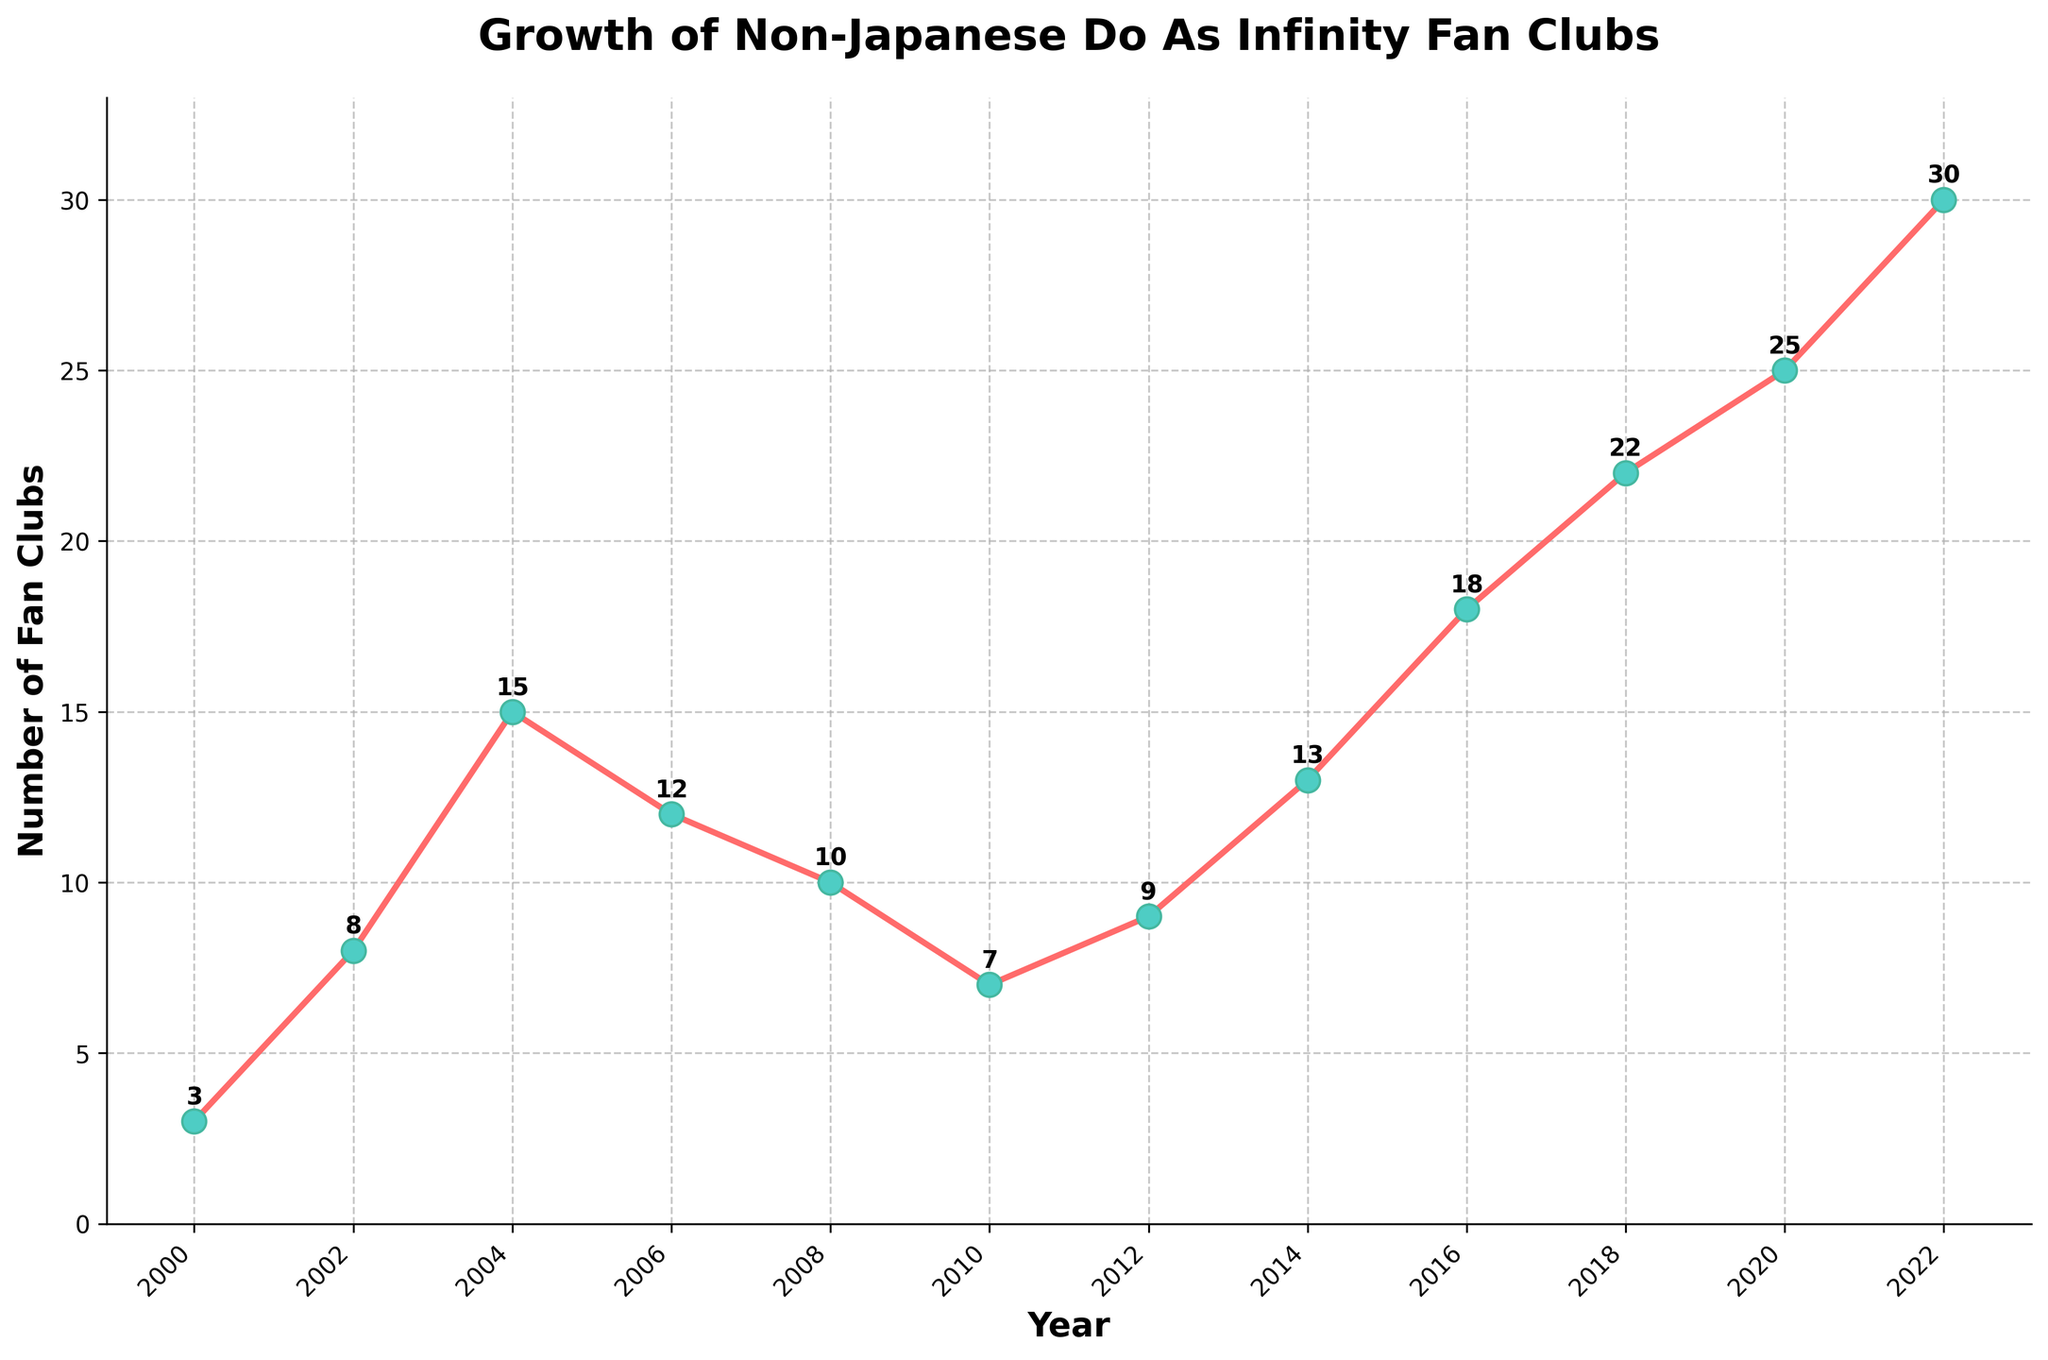How many times did the number of fan clubs decrease compared to the previous year shown in the plot? By counting the instances where the number of fan clubs in a specific year is less than in the previous year: from 2004 to 2006 (15 to 12), from 2006 to 2008 (12 to 10), and from 2008 to 2010 (10 to 7), we see it decreased 3 times.
Answer: 3 Between which years did the number of non-Japanese Do As Infinity fan clubs see the highest increase? Examining the yearly increments: 2002-2004 (8 to 15, increase of 7), 2014-2016 (13 to 18, increase of 5), 2018-2020 (22 to 25, increase of 3), and 2020-2022 (25 to 30, increase of 5); the highest increase is from 2002 to 2004.
Answer: 2002 to 2004 What was the total number of non-Japanese Do As Infinity fan clubs added between 2000 and 2010? Summing the number of fan clubs added each year from 2000 to 2010: (8-3) + (15-8) + (12-15) + (10-12) + (7-10) = 5 + 7 - 3 - 2 - 3 = 4.
Answer: 4 In which year did the number of fan clubs reach 18? By examining each data point on the plot, we see the number of fan clubs reached 18 in the year 2016.
Answer: 2016 What trend is observed from 2010 to 2022 in terms of fan clubs? The plot shows an initial decrease from 2010 to 2012 (7 to 9), followed by a consistent increase from 2012 to 2022, going from 9 to 30.
Answer: An overall increase How many years had fewer than 10 fan clubs? By counting the years where the number of fan clubs was below 10: 2000 (3), 2002 (8), 2008 (10), and 2010 (7); only the years 2000, 2002, and 2010 count as fewer than 10.
Answer: 3 Calculate the average number of fan clubs from 2000 to 2022. Adding up all the yearly numbers of fan clubs: 3 + 8 + 15 + 12 + 10 + 7 + 9 + 13 + 18 + 22 + 25 + 30 = 172 and dividing by the number of years (12): 172/12 ≈ 14.33.
Answer: 14.33 How much did the number of fan clubs change from the highest point before 2010 to the lowest point after 2010? The highest number of fan clubs before 2010 is 15 in 2004, and the lowest after 2010 is 7 in 2010. The change is 15 - 7 = 8.
Answer: 8 Which two-year period saw a decrease in the number of fan clubs immediately followed by an increase? Identifying periods of decrease followed by an increase: 2006-2008 decreased from 12 to 10, followed by an increase to 13 in 2014.
Answer: 2010-2012 